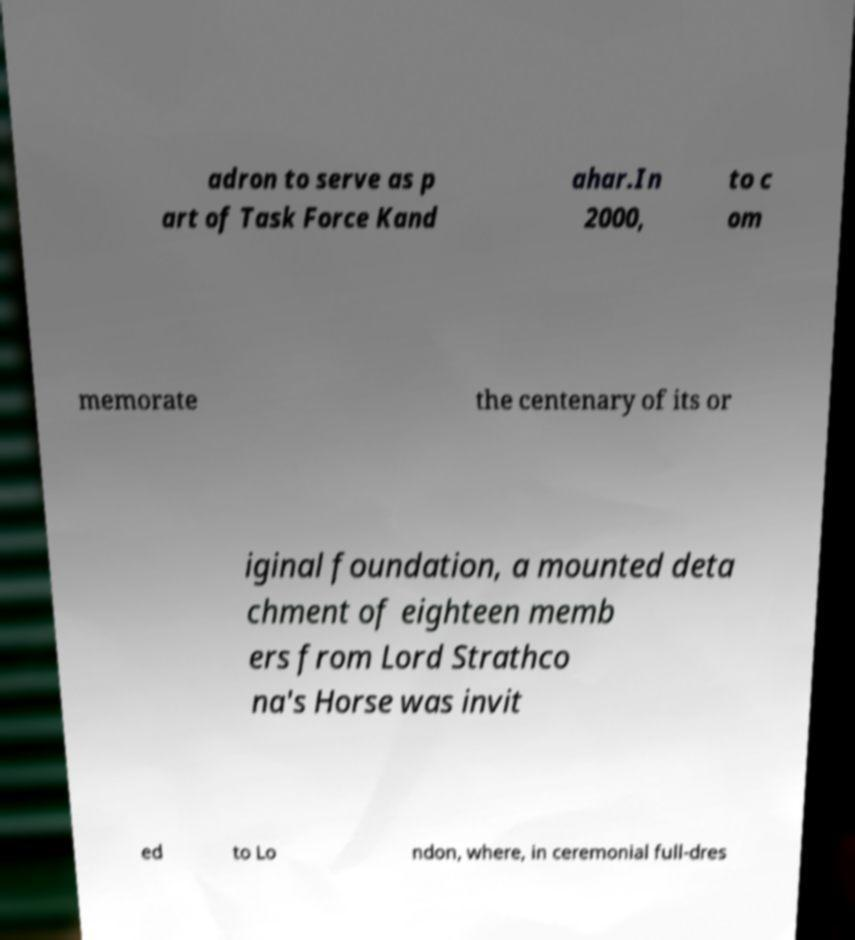Please read and relay the text visible in this image. What does it say? adron to serve as p art of Task Force Kand ahar.In 2000, to c om memorate the centenary of its or iginal foundation, a mounted deta chment of eighteen memb ers from Lord Strathco na's Horse was invit ed to Lo ndon, where, in ceremonial full-dres 